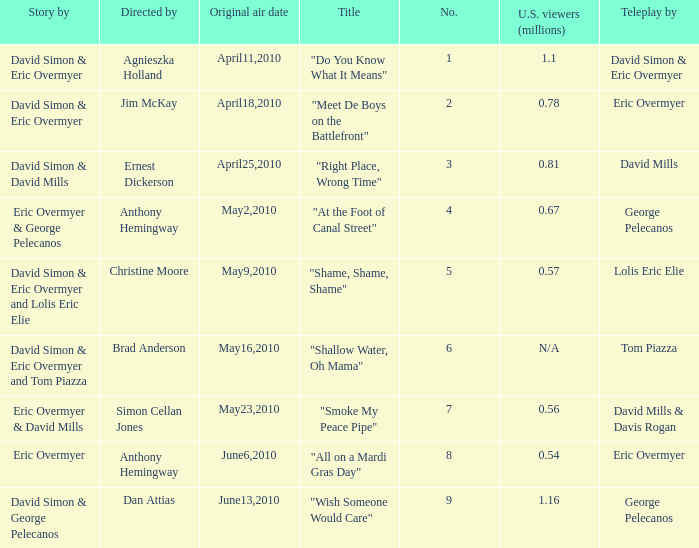Name the teleplay for  david simon & eric overmyer and tom piazza Tom Piazza. 